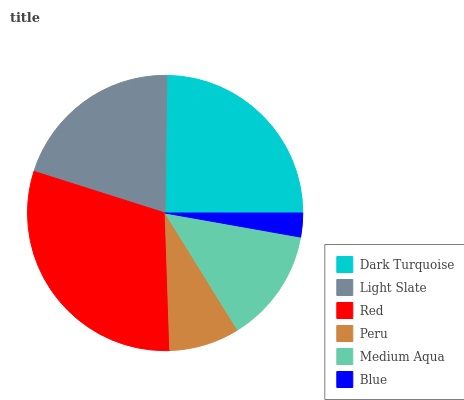Is Blue the minimum?
Answer yes or no. Yes. Is Red the maximum?
Answer yes or no. Yes. Is Light Slate the minimum?
Answer yes or no. No. Is Light Slate the maximum?
Answer yes or no. No. Is Dark Turquoise greater than Light Slate?
Answer yes or no. Yes. Is Light Slate less than Dark Turquoise?
Answer yes or no. Yes. Is Light Slate greater than Dark Turquoise?
Answer yes or no. No. Is Dark Turquoise less than Light Slate?
Answer yes or no. No. Is Light Slate the high median?
Answer yes or no. Yes. Is Medium Aqua the low median?
Answer yes or no. Yes. Is Blue the high median?
Answer yes or no. No. Is Red the low median?
Answer yes or no. No. 